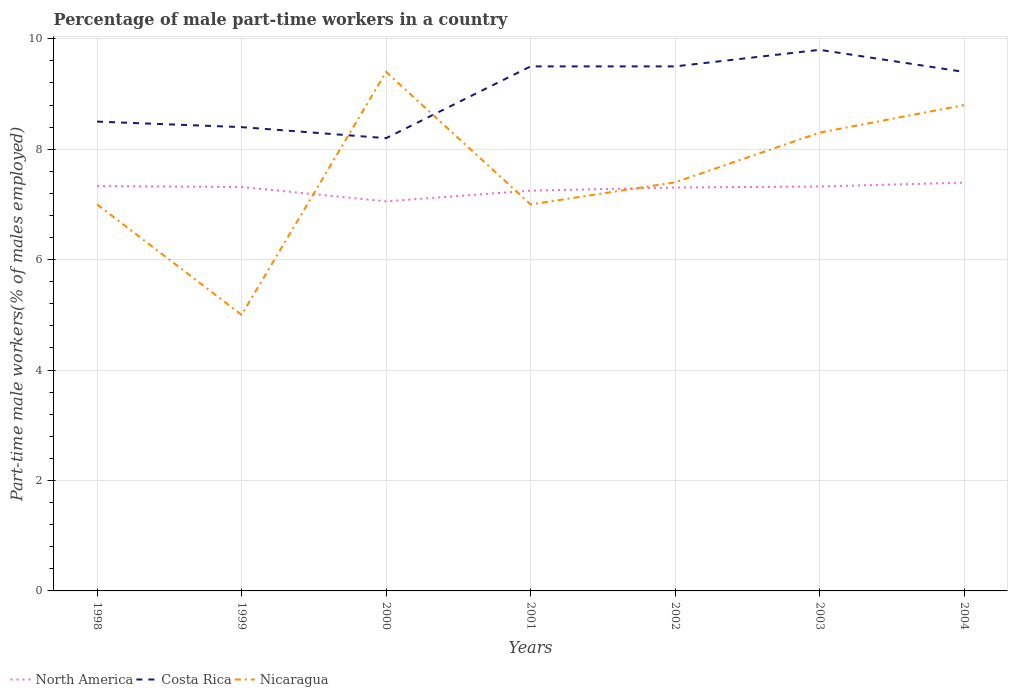Is the number of lines equal to the number of legend labels?
Give a very brief answer. Yes. Across all years, what is the maximum percentage of male part-time workers in Costa Rica?
Ensure brevity in your answer.  8.2. What is the total percentage of male part-time workers in North America in the graph?
Keep it short and to the point. 0.01. What is the difference between the highest and the second highest percentage of male part-time workers in Costa Rica?
Keep it short and to the point. 1.6. Is the percentage of male part-time workers in Nicaragua strictly greater than the percentage of male part-time workers in North America over the years?
Offer a terse response. No. Does the graph contain any zero values?
Your answer should be very brief. No. Does the graph contain grids?
Keep it short and to the point. Yes. Where does the legend appear in the graph?
Ensure brevity in your answer.  Bottom left. What is the title of the graph?
Offer a terse response. Percentage of male part-time workers in a country. Does "Fragile and conflict affected situations" appear as one of the legend labels in the graph?
Offer a very short reply. No. What is the label or title of the X-axis?
Offer a very short reply. Years. What is the label or title of the Y-axis?
Ensure brevity in your answer.  Part-time male workers(% of males employed). What is the Part-time male workers(% of males employed) of North America in 1998?
Offer a terse response. 7.33. What is the Part-time male workers(% of males employed) of North America in 1999?
Ensure brevity in your answer.  7.32. What is the Part-time male workers(% of males employed) of Costa Rica in 1999?
Give a very brief answer. 8.4. What is the Part-time male workers(% of males employed) of Nicaragua in 1999?
Offer a very short reply. 5. What is the Part-time male workers(% of males employed) in North America in 2000?
Offer a very short reply. 7.06. What is the Part-time male workers(% of males employed) in Costa Rica in 2000?
Offer a terse response. 8.2. What is the Part-time male workers(% of males employed) of Nicaragua in 2000?
Give a very brief answer. 9.4. What is the Part-time male workers(% of males employed) in North America in 2001?
Give a very brief answer. 7.25. What is the Part-time male workers(% of males employed) of Costa Rica in 2001?
Your response must be concise. 9.5. What is the Part-time male workers(% of males employed) in North America in 2002?
Make the answer very short. 7.31. What is the Part-time male workers(% of males employed) of Costa Rica in 2002?
Your answer should be very brief. 9.5. What is the Part-time male workers(% of males employed) in Nicaragua in 2002?
Offer a terse response. 7.4. What is the Part-time male workers(% of males employed) of North America in 2003?
Your answer should be compact. 7.33. What is the Part-time male workers(% of males employed) of Costa Rica in 2003?
Your answer should be compact. 9.8. What is the Part-time male workers(% of males employed) in Nicaragua in 2003?
Ensure brevity in your answer.  8.3. What is the Part-time male workers(% of males employed) of North America in 2004?
Keep it short and to the point. 7.39. What is the Part-time male workers(% of males employed) of Costa Rica in 2004?
Ensure brevity in your answer.  9.4. What is the Part-time male workers(% of males employed) of Nicaragua in 2004?
Give a very brief answer. 8.8. Across all years, what is the maximum Part-time male workers(% of males employed) in North America?
Ensure brevity in your answer.  7.39. Across all years, what is the maximum Part-time male workers(% of males employed) of Costa Rica?
Your answer should be very brief. 9.8. Across all years, what is the maximum Part-time male workers(% of males employed) in Nicaragua?
Offer a terse response. 9.4. Across all years, what is the minimum Part-time male workers(% of males employed) in North America?
Ensure brevity in your answer.  7.06. Across all years, what is the minimum Part-time male workers(% of males employed) of Costa Rica?
Ensure brevity in your answer.  8.2. What is the total Part-time male workers(% of males employed) of North America in the graph?
Make the answer very short. 50.98. What is the total Part-time male workers(% of males employed) in Costa Rica in the graph?
Give a very brief answer. 63.3. What is the total Part-time male workers(% of males employed) in Nicaragua in the graph?
Provide a short and direct response. 52.9. What is the difference between the Part-time male workers(% of males employed) in North America in 1998 and that in 1999?
Give a very brief answer. 0.02. What is the difference between the Part-time male workers(% of males employed) in Nicaragua in 1998 and that in 1999?
Your response must be concise. 2. What is the difference between the Part-time male workers(% of males employed) in North America in 1998 and that in 2000?
Make the answer very short. 0.28. What is the difference between the Part-time male workers(% of males employed) of Costa Rica in 1998 and that in 2000?
Offer a terse response. 0.3. What is the difference between the Part-time male workers(% of males employed) in Nicaragua in 1998 and that in 2000?
Your answer should be compact. -2.4. What is the difference between the Part-time male workers(% of males employed) in North America in 1998 and that in 2001?
Your response must be concise. 0.08. What is the difference between the Part-time male workers(% of males employed) in North America in 1998 and that in 2002?
Provide a short and direct response. 0.03. What is the difference between the Part-time male workers(% of males employed) in North America in 1998 and that in 2003?
Make the answer very short. 0.01. What is the difference between the Part-time male workers(% of males employed) in North America in 1998 and that in 2004?
Your response must be concise. -0.06. What is the difference between the Part-time male workers(% of males employed) of Nicaragua in 1998 and that in 2004?
Offer a very short reply. -1.8. What is the difference between the Part-time male workers(% of males employed) in North America in 1999 and that in 2000?
Make the answer very short. 0.26. What is the difference between the Part-time male workers(% of males employed) in North America in 1999 and that in 2001?
Your answer should be very brief. 0.07. What is the difference between the Part-time male workers(% of males employed) in Costa Rica in 1999 and that in 2001?
Your response must be concise. -1.1. What is the difference between the Part-time male workers(% of males employed) of Nicaragua in 1999 and that in 2001?
Your answer should be compact. -2. What is the difference between the Part-time male workers(% of males employed) in North America in 1999 and that in 2002?
Provide a short and direct response. 0.01. What is the difference between the Part-time male workers(% of males employed) of Nicaragua in 1999 and that in 2002?
Your answer should be very brief. -2.4. What is the difference between the Part-time male workers(% of males employed) in North America in 1999 and that in 2003?
Your answer should be very brief. -0.01. What is the difference between the Part-time male workers(% of males employed) of Nicaragua in 1999 and that in 2003?
Make the answer very short. -3.3. What is the difference between the Part-time male workers(% of males employed) in North America in 1999 and that in 2004?
Your response must be concise. -0.08. What is the difference between the Part-time male workers(% of males employed) of Nicaragua in 1999 and that in 2004?
Offer a terse response. -3.8. What is the difference between the Part-time male workers(% of males employed) in North America in 2000 and that in 2001?
Offer a terse response. -0.19. What is the difference between the Part-time male workers(% of males employed) in Costa Rica in 2000 and that in 2001?
Provide a short and direct response. -1.3. What is the difference between the Part-time male workers(% of males employed) of Nicaragua in 2000 and that in 2001?
Offer a terse response. 2.4. What is the difference between the Part-time male workers(% of males employed) of North America in 2000 and that in 2002?
Your answer should be compact. -0.25. What is the difference between the Part-time male workers(% of males employed) in North America in 2000 and that in 2003?
Keep it short and to the point. -0.27. What is the difference between the Part-time male workers(% of males employed) in Nicaragua in 2000 and that in 2003?
Your answer should be compact. 1.1. What is the difference between the Part-time male workers(% of males employed) of North America in 2000 and that in 2004?
Provide a short and direct response. -0.34. What is the difference between the Part-time male workers(% of males employed) in Costa Rica in 2000 and that in 2004?
Ensure brevity in your answer.  -1.2. What is the difference between the Part-time male workers(% of males employed) of Nicaragua in 2000 and that in 2004?
Offer a very short reply. 0.6. What is the difference between the Part-time male workers(% of males employed) of North America in 2001 and that in 2002?
Provide a succinct answer. -0.06. What is the difference between the Part-time male workers(% of males employed) in Costa Rica in 2001 and that in 2002?
Offer a terse response. 0. What is the difference between the Part-time male workers(% of males employed) in North America in 2001 and that in 2003?
Offer a terse response. -0.08. What is the difference between the Part-time male workers(% of males employed) in Costa Rica in 2001 and that in 2003?
Provide a short and direct response. -0.3. What is the difference between the Part-time male workers(% of males employed) in North America in 2001 and that in 2004?
Your answer should be compact. -0.15. What is the difference between the Part-time male workers(% of males employed) of Costa Rica in 2001 and that in 2004?
Provide a succinct answer. 0.1. What is the difference between the Part-time male workers(% of males employed) of North America in 2002 and that in 2003?
Give a very brief answer. -0.02. What is the difference between the Part-time male workers(% of males employed) in Costa Rica in 2002 and that in 2003?
Your answer should be very brief. -0.3. What is the difference between the Part-time male workers(% of males employed) of North America in 2002 and that in 2004?
Your answer should be very brief. -0.09. What is the difference between the Part-time male workers(% of males employed) in North America in 2003 and that in 2004?
Keep it short and to the point. -0.07. What is the difference between the Part-time male workers(% of males employed) of Costa Rica in 2003 and that in 2004?
Your answer should be very brief. 0.4. What is the difference between the Part-time male workers(% of males employed) in North America in 1998 and the Part-time male workers(% of males employed) in Costa Rica in 1999?
Provide a succinct answer. -1.07. What is the difference between the Part-time male workers(% of males employed) of North America in 1998 and the Part-time male workers(% of males employed) of Nicaragua in 1999?
Provide a succinct answer. 2.33. What is the difference between the Part-time male workers(% of males employed) in Costa Rica in 1998 and the Part-time male workers(% of males employed) in Nicaragua in 1999?
Your answer should be very brief. 3.5. What is the difference between the Part-time male workers(% of males employed) in North America in 1998 and the Part-time male workers(% of males employed) in Costa Rica in 2000?
Your response must be concise. -0.87. What is the difference between the Part-time male workers(% of males employed) in North America in 1998 and the Part-time male workers(% of males employed) in Nicaragua in 2000?
Your answer should be very brief. -2.07. What is the difference between the Part-time male workers(% of males employed) in Costa Rica in 1998 and the Part-time male workers(% of males employed) in Nicaragua in 2000?
Give a very brief answer. -0.9. What is the difference between the Part-time male workers(% of males employed) in North America in 1998 and the Part-time male workers(% of males employed) in Costa Rica in 2001?
Your answer should be very brief. -2.17. What is the difference between the Part-time male workers(% of males employed) of North America in 1998 and the Part-time male workers(% of males employed) of Nicaragua in 2001?
Keep it short and to the point. 0.33. What is the difference between the Part-time male workers(% of males employed) in North America in 1998 and the Part-time male workers(% of males employed) in Costa Rica in 2002?
Keep it short and to the point. -2.17. What is the difference between the Part-time male workers(% of males employed) of North America in 1998 and the Part-time male workers(% of males employed) of Nicaragua in 2002?
Your response must be concise. -0.07. What is the difference between the Part-time male workers(% of males employed) of Costa Rica in 1998 and the Part-time male workers(% of males employed) of Nicaragua in 2002?
Provide a short and direct response. 1.1. What is the difference between the Part-time male workers(% of males employed) of North America in 1998 and the Part-time male workers(% of males employed) of Costa Rica in 2003?
Give a very brief answer. -2.47. What is the difference between the Part-time male workers(% of males employed) of North America in 1998 and the Part-time male workers(% of males employed) of Nicaragua in 2003?
Ensure brevity in your answer.  -0.97. What is the difference between the Part-time male workers(% of males employed) of North America in 1998 and the Part-time male workers(% of males employed) of Costa Rica in 2004?
Provide a succinct answer. -2.07. What is the difference between the Part-time male workers(% of males employed) in North America in 1998 and the Part-time male workers(% of males employed) in Nicaragua in 2004?
Offer a terse response. -1.47. What is the difference between the Part-time male workers(% of males employed) of Costa Rica in 1998 and the Part-time male workers(% of males employed) of Nicaragua in 2004?
Offer a terse response. -0.3. What is the difference between the Part-time male workers(% of males employed) of North America in 1999 and the Part-time male workers(% of males employed) of Costa Rica in 2000?
Keep it short and to the point. -0.88. What is the difference between the Part-time male workers(% of males employed) in North America in 1999 and the Part-time male workers(% of males employed) in Nicaragua in 2000?
Provide a succinct answer. -2.08. What is the difference between the Part-time male workers(% of males employed) in North America in 1999 and the Part-time male workers(% of males employed) in Costa Rica in 2001?
Offer a very short reply. -2.18. What is the difference between the Part-time male workers(% of males employed) of North America in 1999 and the Part-time male workers(% of males employed) of Nicaragua in 2001?
Your answer should be compact. 0.32. What is the difference between the Part-time male workers(% of males employed) of North America in 1999 and the Part-time male workers(% of males employed) of Costa Rica in 2002?
Ensure brevity in your answer.  -2.18. What is the difference between the Part-time male workers(% of males employed) in North America in 1999 and the Part-time male workers(% of males employed) in Nicaragua in 2002?
Your answer should be very brief. -0.08. What is the difference between the Part-time male workers(% of males employed) of Costa Rica in 1999 and the Part-time male workers(% of males employed) of Nicaragua in 2002?
Your answer should be very brief. 1. What is the difference between the Part-time male workers(% of males employed) in North America in 1999 and the Part-time male workers(% of males employed) in Costa Rica in 2003?
Provide a succinct answer. -2.48. What is the difference between the Part-time male workers(% of males employed) of North America in 1999 and the Part-time male workers(% of males employed) of Nicaragua in 2003?
Offer a terse response. -0.98. What is the difference between the Part-time male workers(% of males employed) of North America in 1999 and the Part-time male workers(% of males employed) of Costa Rica in 2004?
Provide a succinct answer. -2.08. What is the difference between the Part-time male workers(% of males employed) of North America in 1999 and the Part-time male workers(% of males employed) of Nicaragua in 2004?
Keep it short and to the point. -1.48. What is the difference between the Part-time male workers(% of males employed) of North America in 2000 and the Part-time male workers(% of males employed) of Costa Rica in 2001?
Offer a terse response. -2.44. What is the difference between the Part-time male workers(% of males employed) in North America in 2000 and the Part-time male workers(% of males employed) in Nicaragua in 2001?
Provide a succinct answer. 0.06. What is the difference between the Part-time male workers(% of males employed) in North America in 2000 and the Part-time male workers(% of males employed) in Costa Rica in 2002?
Provide a short and direct response. -2.44. What is the difference between the Part-time male workers(% of males employed) of North America in 2000 and the Part-time male workers(% of males employed) of Nicaragua in 2002?
Provide a short and direct response. -0.34. What is the difference between the Part-time male workers(% of males employed) in North America in 2000 and the Part-time male workers(% of males employed) in Costa Rica in 2003?
Provide a short and direct response. -2.74. What is the difference between the Part-time male workers(% of males employed) in North America in 2000 and the Part-time male workers(% of males employed) in Nicaragua in 2003?
Provide a succinct answer. -1.24. What is the difference between the Part-time male workers(% of males employed) of Costa Rica in 2000 and the Part-time male workers(% of males employed) of Nicaragua in 2003?
Offer a terse response. -0.1. What is the difference between the Part-time male workers(% of males employed) of North America in 2000 and the Part-time male workers(% of males employed) of Costa Rica in 2004?
Give a very brief answer. -2.34. What is the difference between the Part-time male workers(% of males employed) of North America in 2000 and the Part-time male workers(% of males employed) of Nicaragua in 2004?
Make the answer very short. -1.74. What is the difference between the Part-time male workers(% of males employed) in Costa Rica in 2000 and the Part-time male workers(% of males employed) in Nicaragua in 2004?
Your answer should be compact. -0.6. What is the difference between the Part-time male workers(% of males employed) in North America in 2001 and the Part-time male workers(% of males employed) in Costa Rica in 2002?
Your response must be concise. -2.25. What is the difference between the Part-time male workers(% of males employed) of North America in 2001 and the Part-time male workers(% of males employed) of Nicaragua in 2002?
Provide a succinct answer. -0.15. What is the difference between the Part-time male workers(% of males employed) of Costa Rica in 2001 and the Part-time male workers(% of males employed) of Nicaragua in 2002?
Give a very brief answer. 2.1. What is the difference between the Part-time male workers(% of males employed) of North America in 2001 and the Part-time male workers(% of males employed) of Costa Rica in 2003?
Keep it short and to the point. -2.55. What is the difference between the Part-time male workers(% of males employed) in North America in 2001 and the Part-time male workers(% of males employed) in Nicaragua in 2003?
Your response must be concise. -1.05. What is the difference between the Part-time male workers(% of males employed) in North America in 2001 and the Part-time male workers(% of males employed) in Costa Rica in 2004?
Make the answer very short. -2.15. What is the difference between the Part-time male workers(% of males employed) of North America in 2001 and the Part-time male workers(% of males employed) of Nicaragua in 2004?
Make the answer very short. -1.55. What is the difference between the Part-time male workers(% of males employed) of Costa Rica in 2001 and the Part-time male workers(% of males employed) of Nicaragua in 2004?
Ensure brevity in your answer.  0.7. What is the difference between the Part-time male workers(% of males employed) in North America in 2002 and the Part-time male workers(% of males employed) in Costa Rica in 2003?
Provide a succinct answer. -2.49. What is the difference between the Part-time male workers(% of males employed) of North America in 2002 and the Part-time male workers(% of males employed) of Nicaragua in 2003?
Provide a short and direct response. -0.99. What is the difference between the Part-time male workers(% of males employed) in Costa Rica in 2002 and the Part-time male workers(% of males employed) in Nicaragua in 2003?
Ensure brevity in your answer.  1.2. What is the difference between the Part-time male workers(% of males employed) in North America in 2002 and the Part-time male workers(% of males employed) in Costa Rica in 2004?
Offer a terse response. -2.09. What is the difference between the Part-time male workers(% of males employed) of North America in 2002 and the Part-time male workers(% of males employed) of Nicaragua in 2004?
Your answer should be very brief. -1.49. What is the difference between the Part-time male workers(% of males employed) of Costa Rica in 2002 and the Part-time male workers(% of males employed) of Nicaragua in 2004?
Give a very brief answer. 0.7. What is the difference between the Part-time male workers(% of males employed) of North America in 2003 and the Part-time male workers(% of males employed) of Costa Rica in 2004?
Keep it short and to the point. -2.07. What is the difference between the Part-time male workers(% of males employed) of North America in 2003 and the Part-time male workers(% of males employed) of Nicaragua in 2004?
Ensure brevity in your answer.  -1.47. What is the average Part-time male workers(% of males employed) of North America per year?
Make the answer very short. 7.28. What is the average Part-time male workers(% of males employed) in Costa Rica per year?
Your response must be concise. 9.04. What is the average Part-time male workers(% of males employed) of Nicaragua per year?
Provide a succinct answer. 7.56. In the year 1998, what is the difference between the Part-time male workers(% of males employed) in North America and Part-time male workers(% of males employed) in Costa Rica?
Offer a very short reply. -1.17. In the year 1998, what is the difference between the Part-time male workers(% of males employed) of North America and Part-time male workers(% of males employed) of Nicaragua?
Provide a succinct answer. 0.33. In the year 1998, what is the difference between the Part-time male workers(% of males employed) in Costa Rica and Part-time male workers(% of males employed) in Nicaragua?
Give a very brief answer. 1.5. In the year 1999, what is the difference between the Part-time male workers(% of males employed) of North America and Part-time male workers(% of males employed) of Costa Rica?
Offer a terse response. -1.08. In the year 1999, what is the difference between the Part-time male workers(% of males employed) of North America and Part-time male workers(% of males employed) of Nicaragua?
Provide a short and direct response. 2.32. In the year 1999, what is the difference between the Part-time male workers(% of males employed) in Costa Rica and Part-time male workers(% of males employed) in Nicaragua?
Keep it short and to the point. 3.4. In the year 2000, what is the difference between the Part-time male workers(% of males employed) in North America and Part-time male workers(% of males employed) in Costa Rica?
Ensure brevity in your answer.  -1.14. In the year 2000, what is the difference between the Part-time male workers(% of males employed) in North America and Part-time male workers(% of males employed) in Nicaragua?
Provide a succinct answer. -2.34. In the year 2001, what is the difference between the Part-time male workers(% of males employed) of North America and Part-time male workers(% of males employed) of Costa Rica?
Keep it short and to the point. -2.25. In the year 2001, what is the difference between the Part-time male workers(% of males employed) of North America and Part-time male workers(% of males employed) of Nicaragua?
Provide a succinct answer. 0.25. In the year 2002, what is the difference between the Part-time male workers(% of males employed) in North America and Part-time male workers(% of males employed) in Costa Rica?
Your answer should be very brief. -2.19. In the year 2002, what is the difference between the Part-time male workers(% of males employed) of North America and Part-time male workers(% of males employed) of Nicaragua?
Your response must be concise. -0.09. In the year 2002, what is the difference between the Part-time male workers(% of males employed) of Costa Rica and Part-time male workers(% of males employed) of Nicaragua?
Your answer should be compact. 2.1. In the year 2003, what is the difference between the Part-time male workers(% of males employed) of North America and Part-time male workers(% of males employed) of Costa Rica?
Make the answer very short. -2.47. In the year 2003, what is the difference between the Part-time male workers(% of males employed) of North America and Part-time male workers(% of males employed) of Nicaragua?
Provide a succinct answer. -0.97. In the year 2004, what is the difference between the Part-time male workers(% of males employed) of North America and Part-time male workers(% of males employed) of Costa Rica?
Provide a short and direct response. -2.01. In the year 2004, what is the difference between the Part-time male workers(% of males employed) of North America and Part-time male workers(% of males employed) of Nicaragua?
Ensure brevity in your answer.  -1.41. What is the ratio of the Part-time male workers(% of males employed) in North America in 1998 to that in 1999?
Your answer should be very brief. 1. What is the ratio of the Part-time male workers(% of males employed) in Costa Rica in 1998 to that in 1999?
Give a very brief answer. 1.01. What is the ratio of the Part-time male workers(% of males employed) of North America in 1998 to that in 2000?
Your answer should be compact. 1.04. What is the ratio of the Part-time male workers(% of males employed) of Costa Rica in 1998 to that in 2000?
Offer a very short reply. 1.04. What is the ratio of the Part-time male workers(% of males employed) in Nicaragua in 1998 to that in 2000?
Keep it short and to the point. 0.74. What is the ratio of the Part-time male workers(% of males employed) of North America in 1998 to that in 2001?
Make the answer very short. 1.01. What is the ratio of the Part-time male workers(% of males employed) in Costa Rica in 1998 to that in 2001?
Provide a succinct answer. 0.89. What is the ratio of the Part-time male workers(% of males employed) of Nicaragua in 1998 to that in 2001?
Offer a terse response. 1. What is the ratio of the Part-time male workers(% of males employed) in Costa Rica in 1998 to that in 2002?
Your response must be concise. 0.89. What is the ratio of the Part-time male workers(% of males employed) in Nicaragua in 1998 to that in 2002?
Give a very brief answer. 0.95. What is the ratio of the Part-time male workers(% of males employed) in North America in 1998 to that in 2003?
Your response must be concise. 1. What is the ratio of the Part-time male workers(% of males employed) in Costa Rica in 1998 to that in 2003?
Ensure brevity in your answer.  0.87. What is the ratio of the Part-time male workers(% of males employed) of Nicaragua in 1998 to that in 2003?
Your response must be concise. 0.84. What is the ratio of the Part-time male workers(% of males employed) in Costa Rica in 1998 to that in 2004?
Provide a succinct answer. 0.9. What is the ratio of the Part-time male workers(% of males employed) in Nicaragua in 1998 to that in 2004?
Ensure brevity in your answer.  0.8. What is the ratio of the Part-time male workers(% of males employed) of North America in 1999 to that in 2000?
Your answer should be very brief. 1.04. What is the ratio of the Part-time male workers(% of males employed) of Costa Rica in 1999 to that in 2000?
Keep it short and to the point. 1.02. What is the ratio of the Part-time male workers(% of males employed) in Nicaragua in 1999 to that in 2000?
Your answer should be very brief. 0.53. What is the ratio of the Part-time male workers(% of males employed) in North America in 1999 to that in 2001?
Offer a terse response. 1.01. What is the ratio of the Part-time male workers(% of males employed) of Costa Rica in 1999 to that in 2001?
Ensure brevity in your answer.  0.88. What is the ratio of the Part-time male workers(% of males employed) in Nicaragua in 1999 to that in 2001?
Provide a short and direct response. 0.71. What is the ratio of the Part-time male workers(% of males employed) in North America in 1999 to that in 2002?
Offer a terse response. 1. What is the ratio of the Part-time male workers(% of males employed) of Costa Rica in 1999 to that in 2002?
Offer a terse response. 0.88. What is the ratio of the Part-time male workers(% of males employed) of Nicaragua in 1999 to that in 2002?
Keep it short and to the point. 0.68. What is the ratio of the Part-time male workers(% of males employed) of Costa Rica in 1999 to that in 2003?
Ensure brevity in your answer.  0.86. What is the ratio of the Part-time male workers(% of males employed) in Nicaragua in 1999 to that in 2003?
Make the answer very short. 0.6. What is the ratio of the Part-time male workers(% of males employed) of North America in 1999 to that in 2004?
Keep it short and to the point. 0.99. What is the ratio of the Part-time male workers(% of males employed) in Costa Rica in 1999 to that in 2004?
Your answer should be very brief. 0.89. What is the ratio of the Part-time male workers(% of males employed) in Nicaragua in 1999 to that in 2004?
Provide a succinct answer. 0.57. What is the ratio of the Part-time male workers(% of males employed) of North America in 2000 to that in 2001?
Keep it short and to the point. 0.97. What is the ratio of the Part-time male workers(% of males employed) of Costa Rica in 2000 to that in 2001?
Your response must be concise. 0.86. What is the ratio of the Part-time male workers(% of males employed) in Nicaragua in 2000 to that in 2001?
Make the answer very short. 1.34. What is the ratio of the Part-time male workers(% of males employed) of North America in 2000 to that in 2002?
Offer a terse response. 0.97. What is the ratio of the Part-time male workers(% of males employed) of Costa Rica in 2000 to that in 2002?
Provide a succinct answer. 0.86. What is the ratio of the Part-time male workers(% of males employed) of Nicaragua in 2000 to that in 2002?
Offer a very short reply. 1.27. What is the ratio of the Part-time male workers(% of males employed) of North America in 2000 to that in 2003?
Your answer should be very brief. 0.96. What is the ratio of the Part-time male workers(% of males employed) of Costa Rica in 2000 to that in 2003?
Your answer should be very brief. 0.84. What is the ratio of the Part-time male workers(% of males employed) of Nicaragua in 2000 to that in 2003?
Make the answer very short. 1.13. What is the ratio of the Part-time male workers(% of males employed) of North America in 2000 to that in 2004?
Provide a short and direct response. 0.95. What is the ratio of the Part-time male workers(% of males employed) of Costa Rica in 2000 to that in 2004?
Ensure brevity in your answer.  0.87. What is the ratio of the Part-time male workers(% of males employed) of Nicaragua in 2000 to that in 2004?
Give a very brief answer. 1.07. What is the ratio of the Part-time male workers(% of males employed) of North America in 2001 to that in 2002?
Keep it short and to the point. 0.99. What is the ratio of the Part-time male workers(% of males employed) in Nicaragua in 2001 to that in 2002?
Offer a terse response. 0.95. What is the ratio of the Part-time male workers(% of males employed) of North America in 2001 to that in 2003?
Your answer should be compact. 0.99. What is the ratio of the Part-time male workers(% of males employed) in Costa Rica in 2001 to that in 2003?
Offer a very short reply. 0.97. What is the ratio of the Part-time male workers(% of males employed) of Nicaragua in 2001 to that in 2003?
Provide a succinct answer. 0.84. What is the ratio of the Part-time male workers(% of males employed) in North America in 2001 to that in 2004?
Your answer should be compact. 0.98. What is the ratio of the Part-time male workers(% of males employed) in Costa Rica in 2001 to that in 2004?
Your answer should be very brief. 1.01. What is the ratio of the Part-time male workers(% of males employed) in Nicaragua in 2001 to that in 2004?
Make the answer very short. 0.8. What is the ratio of the Part-time male workers(% of males employed) in Costa Rica in 2002 to that in 2003?
Offer a very short reply. 0.97. What is the ratio of the Part-time male workers(% of males employed) in Nicaragua in 2002 to that in 2003?
Give a very brief answer. 0.89. What is the ratio of the Part-time male workers(% of males employed) in Costa Rica in 2002 to that in 2004?
Keep it short and to the point. 1.01. What is the ratio of the Part-time male workers(% of males employed) in Nicaragua in 2002 to that in 2004?
Make the answer very short. 0.84. What is the ratio of the Part-time male workers(% of males employed) of North America in 2003 to that in 2004?
Provide a short and direct response. 0.99. What is the ratio of the Part-time male workers(% of males employed) of Costa Rica in 2003 to that in 2004?
Offer a terse response. 1.04. What is the ratio of the Part-time male workers(% of males employed) in Nicaragua in 2003 to that in 2004?
Offer a terse response. 0.94. What is the difference between the highest and the second highest Part-time male workers(% of males employed) of North America?
Offer a terse response. 0.06. What is the difference between the highest and the second highest Part-time male workers(% of males employed) of Costa Rica?
Ensure brevity in your answer.  0.3. What is the difference between the highest and the second highest Part-time male workers(% of males employed) of Nicaragua?
Your response must be concise. 0.6. What is the difference between the highest and the lowest Part-time male workers(% of males employed) of North America?
Your answer should be compact. 0.34. What is the difference between the highest and the lowest Part-time male workers(% of males employed) in Costa Rica?
Make the answer very short. 1.6. What is the difference between the highest and the lowest Part-time male workers(% of males employed) of Nicaragua?
Offer a very short reply. 4.4. 